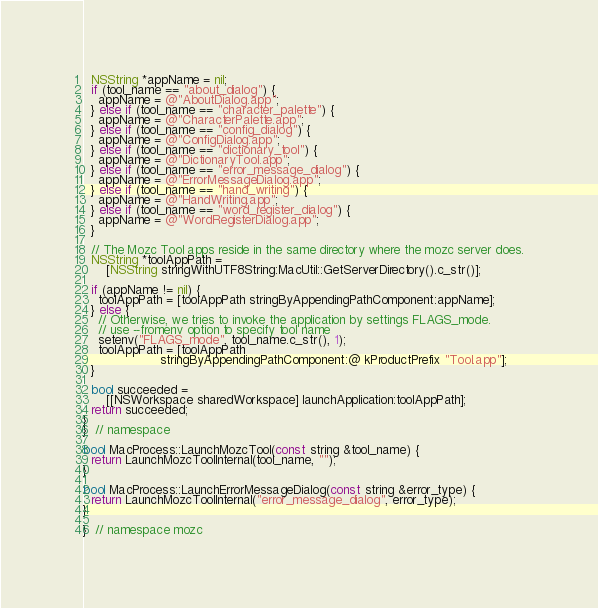<code> <loc_0><loc_0><loc_500><loc_500><_ObjectiveC_>  NSString *appName = nil;
  if (tool_name == "about_dialog") {
    appName = @"AboutDialog.app";
  } else if (tool_name == "character_palette") {
    appName = @"CharacterPalette.app";
  } else if (tool_name == "config_dialog") {
    appName = @"ConfigDialog.app";
  } else if (tool_name == "dictionary_tool") {
    appName = @"DictionaryTool.app";
  } else if (tool_name == "error_message_dialog") {
    appName = @"ErrorMessageDialog.app";
  } else if (tool_name == "hand_writing") {
    appName = @"HandWriting.app";
  } else if (tool_name == "word_register_dialog") {
    appName = @"WordRegisterDialog.app";
  }

  // The Mozc Tool apps reside in the same directory where the mozc server does.
  NSString *toolAppPath =
      [NSString stringWithUTF8String:MacUtil::GetServerDirectory().c_str()];

  if (appName != nil) {
    toolAppPath = [toolAppPath stringByAppendingPathComponent:appName];
  } else {
    // Otherwise, we tries to invoke the application by settings FLAGS_mode.
    // use --fromenv option to specify tool name
    setenv("FLAGS_mode", tool_name.c_str(), 1);
    toolAppPath = [toolAppPath
                    stringByAppendingPathComponent:@ kProductPrefix "Tool.app"];
  }

  bool succeeded =
      [[NSWorkspace sharedWorkspace] launchApplication:toolAppPath];
  return succeeded;
}
}  // namespace

bool MacProcess::LaunchMozcTool(const string &tool_name) {
  return LaunchMozcToolInternal(tool_name, "");
}

bool MacProcess::LaunchErrorMessageDialog(const string &error_type) {
  return LaunchMozcToolInternal("error_message_dialog", error_type);
}

}  // namespace mozc
</code> 